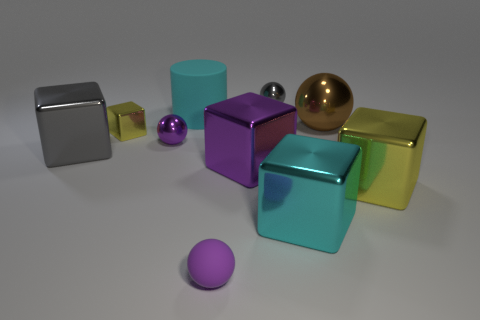Subtract all purple cubes. How many cubes are left? 4 Subtract all large gray blocks. How many blocks are left? 4 Subtract all brown cubes. Subtract all gray cylinders. How many cubes are left? 5 Subtract all cylinders. How many objects are left? 9 Add 3 small purple matte objects. How many small purple matte objects exist? 4 Subtract 0 brown blocks. How many objects are left? 10 Subtract all big yellow rubber things. Subtract all large yellow objects. How many objects are left? 9 Add 7 large spheres. How many large spheres are left? 8 